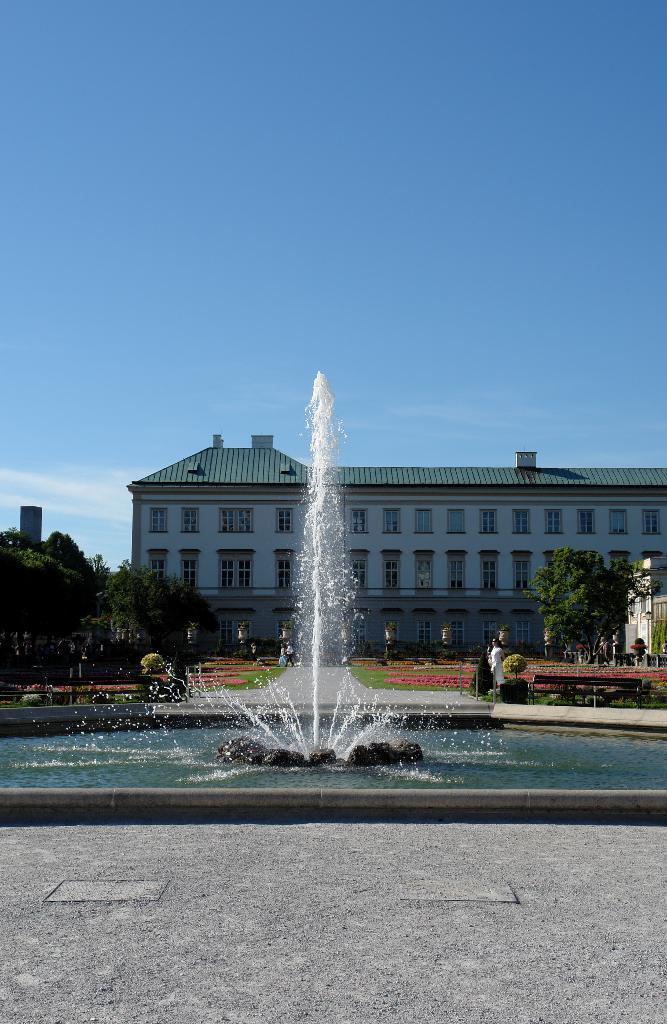Please provide a concise description of this image. In this image, I can see a water fountain. On the right side of the image, I can see a bench. There are trees, buildings and few people. In the background, there is the sky. 